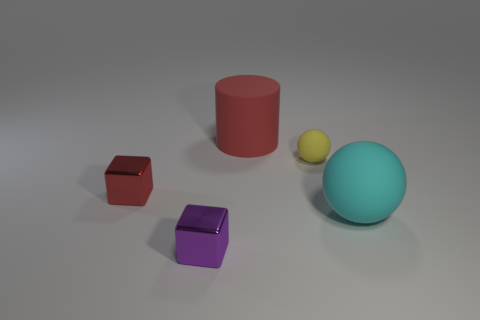Add 4 cyan rubber objects. How many objects exist? 9 Subtract all cylinders. How many objects are left? 4 Subtract all small rubber objects. Subtract all small red metal blocks. How many objects are left? 3 Add 4 large cyan rubber balls. How many large cyan rubber balls are left? 5 Add 2 yellow rubber balls. How many yellow rubber balls exist? 3 Subtract 0 brown cubes. How many objects are left? 5 